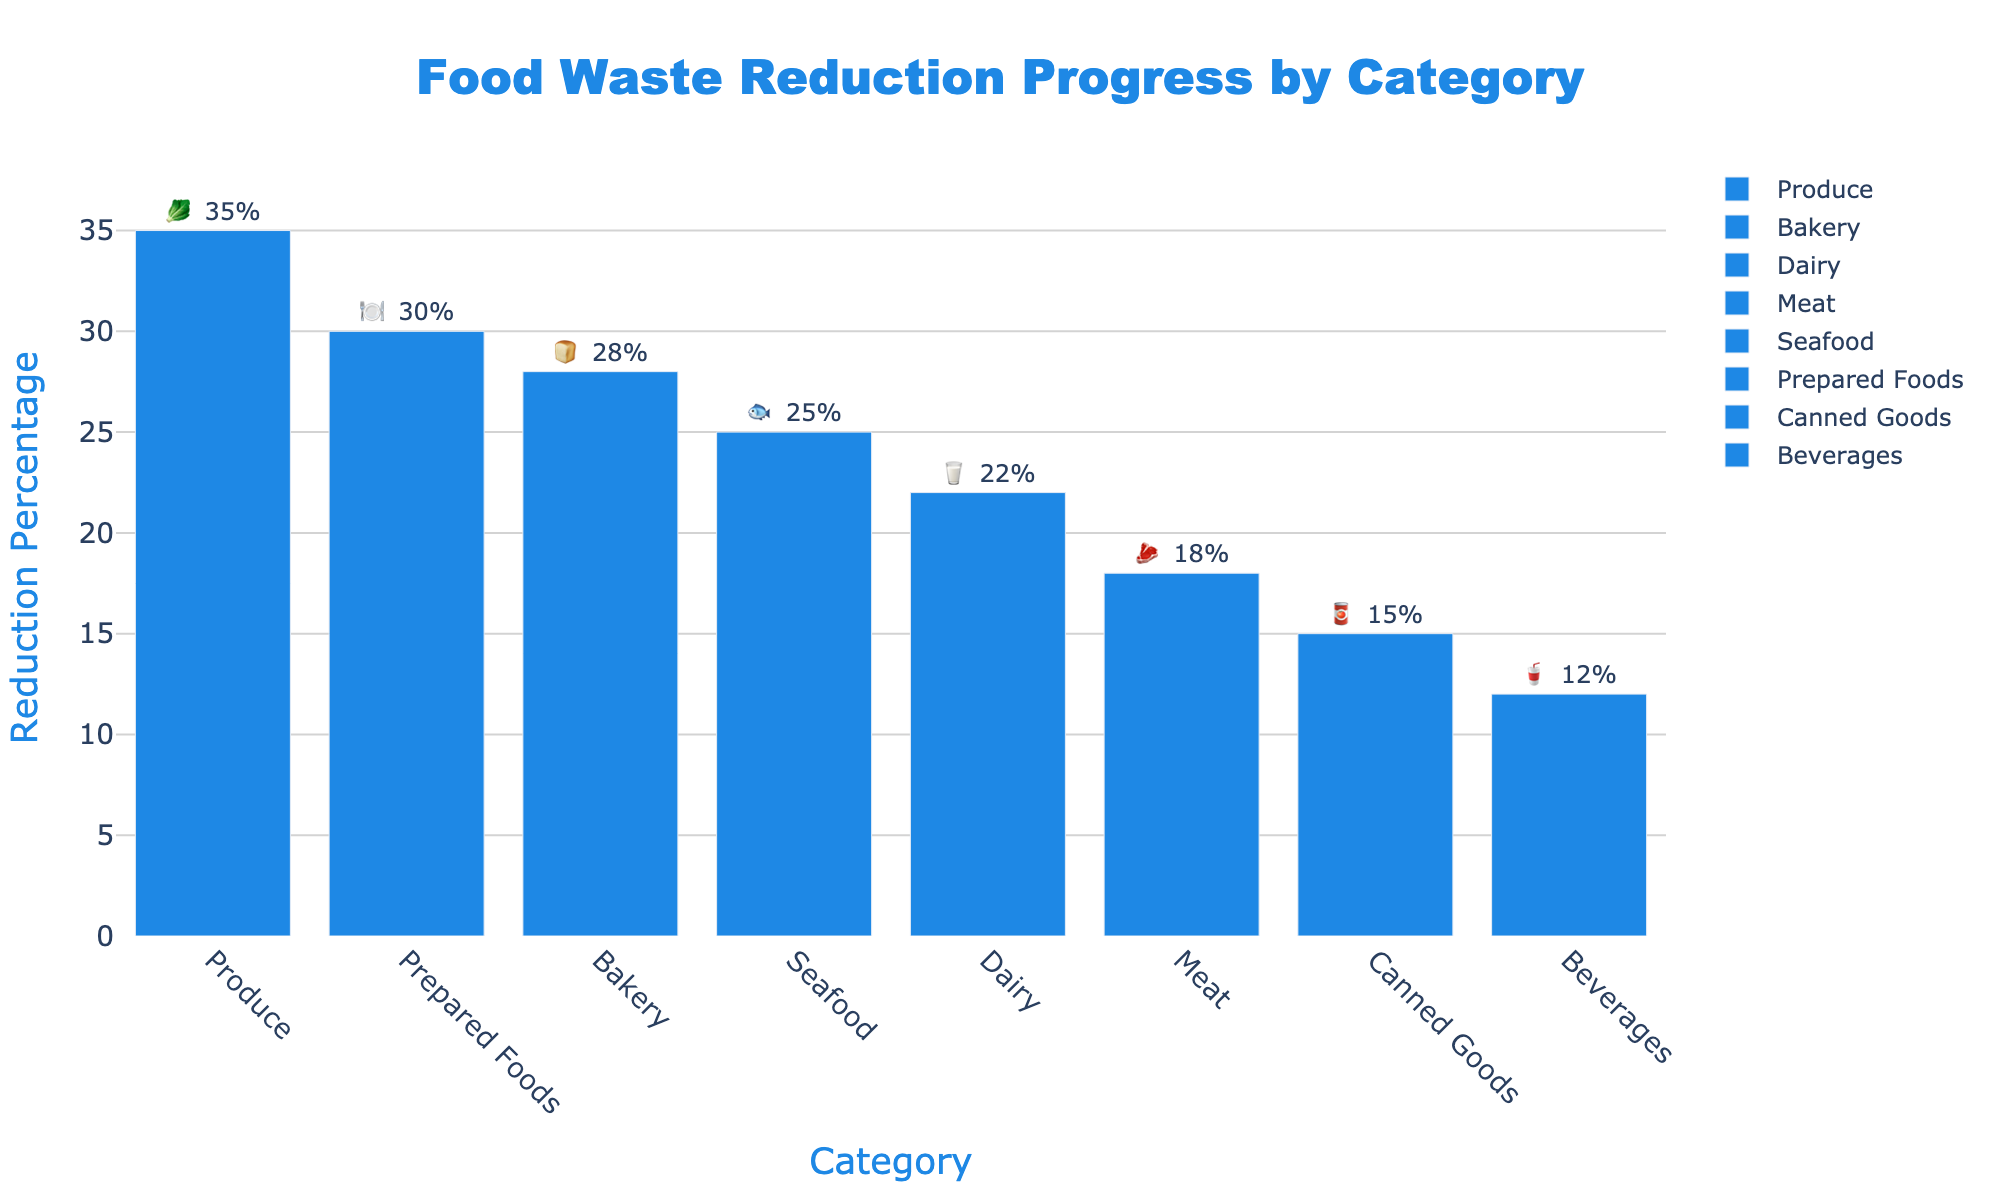Which category has the highest reduction percentage? The category with the highest reduction percentage is determined by looking for the tallest bar or highest value on the y-axis. Produce has a reduction percentage of 35%, which is the maximum.
Answer: Produce What's the title of the chart? The title is located at the top of the chart. It reads "Food Waste Reduction Progress by Category".
Answer: Food Waste Reduction Progress by Category What is the reduction percentage for Prepared Foods? To find the reduction percentage for Prepared Foods, locate the bar labeled "Prepared Foods" on the x-axis and read its corresponding value on the y-axis. The reduction percentage is 30%.
Answer: 30% How many categories have a reduction percentage greater than 20%? Identify bars that exceed the 20% mark on the y-axis. Produce (35%), Bakery (28%), Dairy (22%), Seafood (25%), and Prepared Foods (30%) meet this criterion. There are 5 such categories.
Answer: 5 What is the combined reduction percentage for Dairy and Seafood? Add the reduction percentage values for Dairy (22%) and Seafood (25%). This results in a combined reduction percentage of 47%.
Answer: 47% Which categories have a reduction percentage lower than 25%? Identify categories with bars that fall below the 25% mark on the y-axis. These are Dairy (22%), Meat (18%), Canned Goods (15%), and Beverages (12%).
Answer: Dairy, Meat, Canned Goods, Beverages What is the difference in reduction percentage between Bakery and Beverages? Subtract the reduction percentage of Beverages (12%) from that of Bakery (28%). The difference is 16%.
Answer: 16% Among meat, bakery, and seafood, which has the lowest reduction percentage? Compare the reduction percentages of Meat (18%), Bakery (28%), and Seafood (25%). Meat has the lowest reduction percentage at 18%.
Answer: Meat What is the average reduction percentage of all categories? The sum of all reduction percentages is (35 + 28 + 22 + 18 + 25 + 30 + 15 + 12) = 185. Dividing this sum by the number of categories (8), the average is 185/8 = 23.125.
Answer: ~23.1% Which emoji represents the category with the second highest reduction percentage? The category with the second highest reduction percentage is Bakery, with 28%. The corresponding emoji is 🍞.
Answer: 🍞 